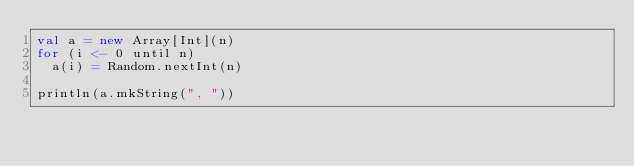Convert code to text. <code><loc_0><loc_0><loc_500><loc_500><_Scala_>val a = new Array[Int](n)
for (i <- 0 until n)
  a(i) = Random.nextInt(n)

println(a.mkString(", "))
</code> 